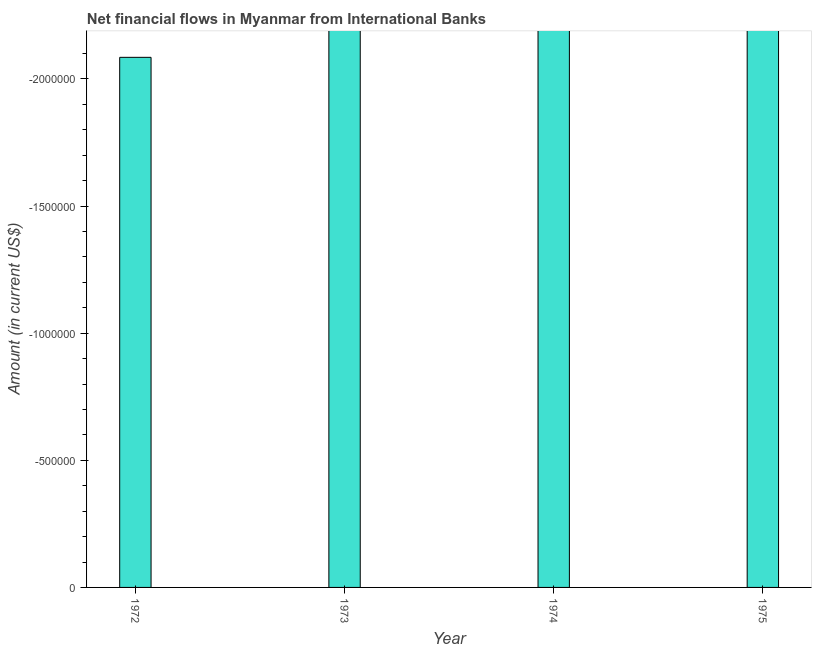What is the title of the graph?
Provide a short and direct response. Net financial flows in Myanmar from International Banks. What is the label or title of the X-axis?
Give a very brief answer. Year. What is the label or title of the Y-axis?
Offer a very short reply. Amount (in current US$). In how many years, is the net financial flows from ibrd greater than -1600000 US$?
Provide a short and direct response. 0. In how many years, is the net financial flows from ibrd greater than the average net financial flows from ibrd taken over all years?
Provide a short and direct response. 0. How many bars are there?
Give a very brief answer. 0. Are all the bars in the graph horizontal?
Provide a succinct answer. No. How many years are there in the graph?
Provide a short and direct response. 4. What is the Amount (in current US$) of 1972?
Your answer should be compact. 0. What is the Amount (in current US$) of 1973?
Offer a terse response. 0. 